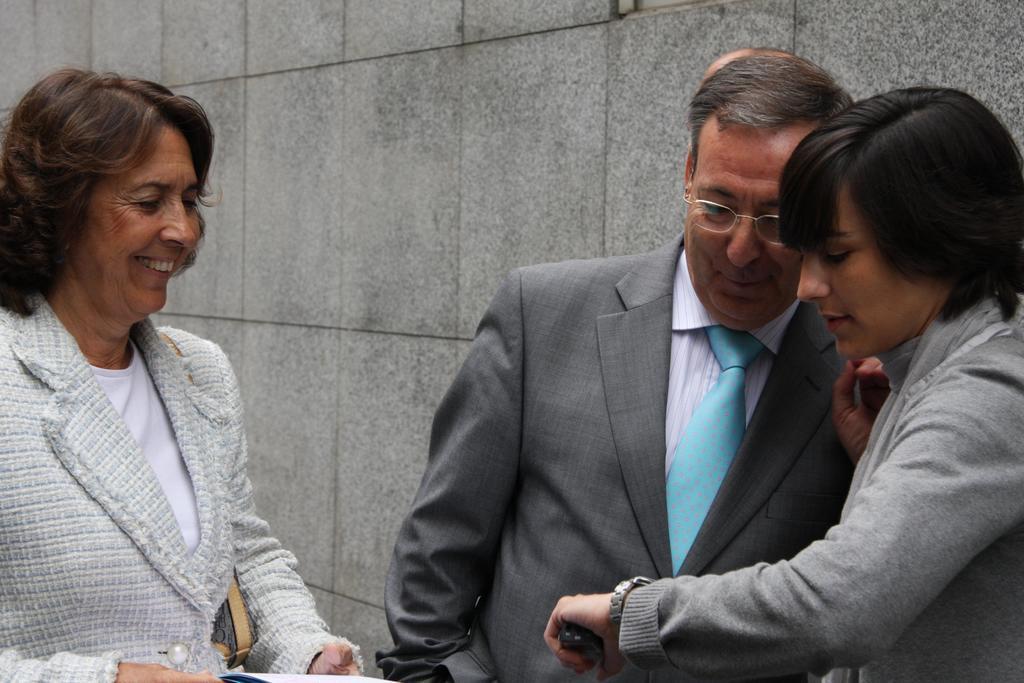Describe this image in one or two sentences. In this image we can see three persons. Middle person is wearing specs. Person on the right is wearing a watch. In the back there is a wall. 